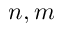<formula> <loc_0><loc_0><loc_500><loc_500>n , m</formula> 